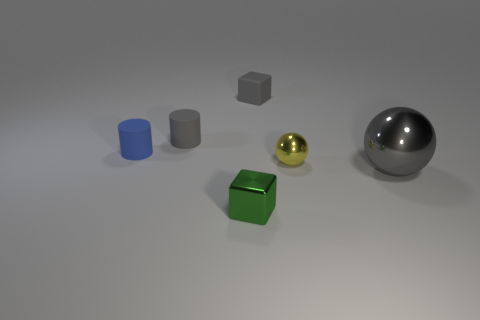The sphere that is the same color as the rubber block is what size?
Provide a short and direct response. Large. Is there a tiny green object made of the same material as the big object?
Your answer should be very brief. Yes. Are the small gray object left of the gray cube and the block that is behind the small blue thing made of the same material?
Your answer should be compact. Yes. How many large gray rubber spheres are there?
Offer a very short reply. 0. What shape is the small shiny thing that is right of the tiny shiny block?
Your answer should be compact. Sphere. What number of other things are there of the same size as the blue thing?
Your response must be concise. 4. There is a gray object that is on the left side of the tiny gray matte cube; is its shape the same as the matte object that is to the left of the small gray cylinder?
Make the answer very short. Yes. How many shiny blocks are to the right of the tiny gray matte block?
Make the answer very short. 0. What color is the thing to the right of the yellow metal ball?
Make the answer very short. Gray. There is another small object that is the same shape as the green thing; what is its color?
Your answer should be compact. Gray. 